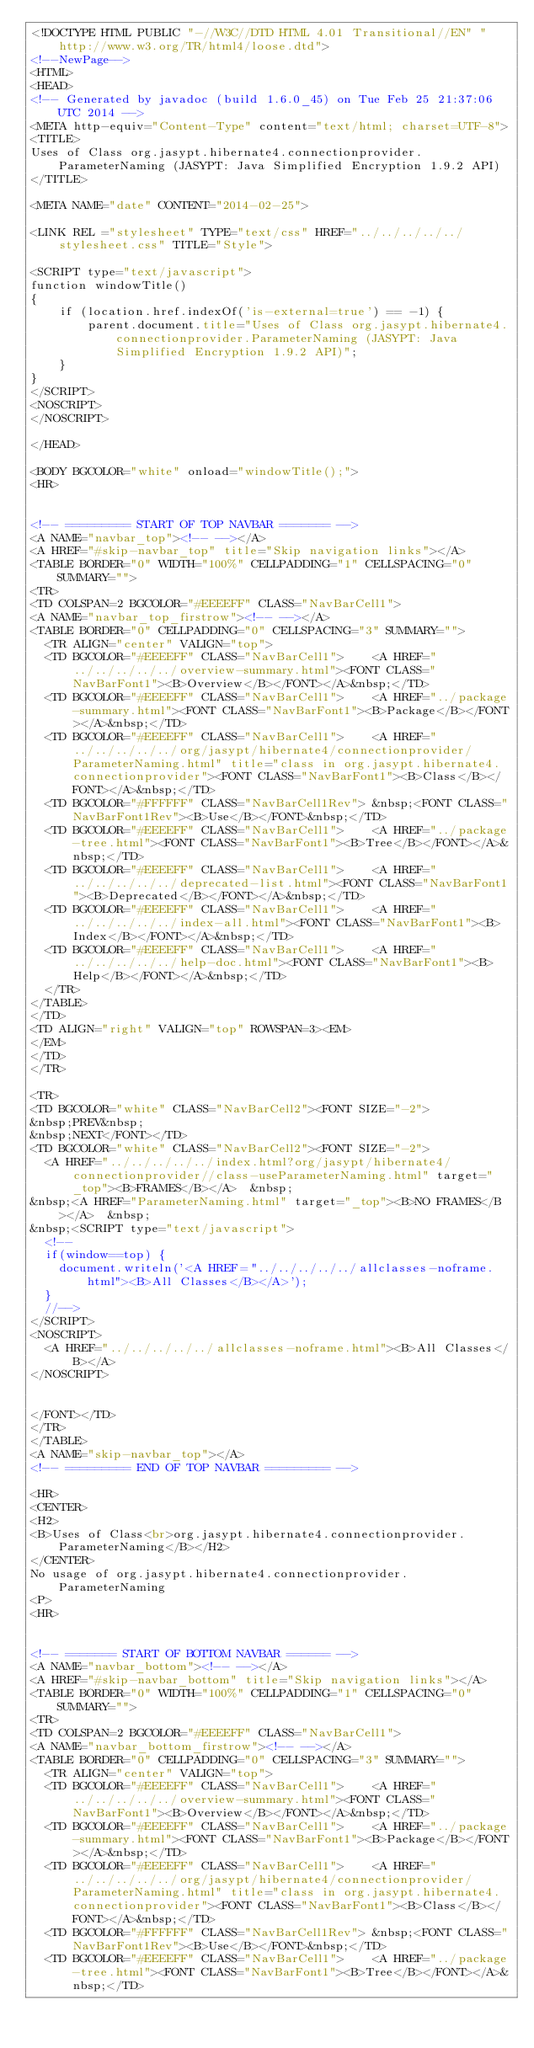Convert code to text. <code><loc_0><loc_0><loc_500><loc_500><_HTML_><!DOCTYPE HTML PUBLIC "-//W3C//DTD HTML 4.01 Transitional//EN" "http://www.w3.org/TR/html4/loose.dtd">
<!--NewPage-->
<HTML>
<HEAD>
<!-- Generated by javadoc (build 1.6.0_45) on Tue Feb 25 21:37:06 UTC 2014 -->
<META http-equiv="Content-Type" content="text/html; charset=UTF-8">
<TITLE>
Uses of Class org.jasypt.hibernate4.connectionprovider.ParameterNaming (JASYPT: Java Simplified Encryption 1.9.2 API)
</TITLE>

<META NAME="date" CONTENT="2014-02-25">

<LINK REL ="stylesheet" TYPE="text/css" HREF="../../../../../stylesheet.css" TITLE="Style">

<SCRIPT type="text/javascript">
function windowTitle()
{
    if (location.href.indexOf('is-external=true') == -1) {
        parent.document.title="Uses of Class org.jasypt.hibernate4.connectionprovider.ParameterNaming (JASYPT: Java Simplified Encryption 1.9.2 API)";
    }
}
</SCRIPT>
<NOSCRIPT>
</NOSCRIPT>

</HEAD>

<BODY BGCOLOR="white" onload="windowTitle();">
<HR>


<!-- ========= START OF TOP NAVBAR ======= -->
<A NAME="navbar_top"><!-- --></A>
<A HREF="#skip-navbar_top" title="Skip navigation links"></A>
<TABLE BORDER="0" WIDTH="100%" CELLPADDING="1" CELLSPACING="0" SUMMARY="">
<TR>
<TD COLSPAN=2 BGCOLOR="#EEEEFF" CLASS="NavBarCell1">
<A NAME="navbar_top_firstrow"><!-- --></A>
<TABLE BORDER="0" CELLPADDING="0" CELLSPACING="3" SUMMARY="">
  <TR ALIGN="center" VALIGN="top">
  <TD BGCOLOR="#EEEEFF" CLASS="NavBarCell1">    <A HREF="../../../../../overview-summary.html"><FONT CLASS="NavBarFont1"><B>Overview</B></FONT></A>&nbsp;</TD>
  <TD BGCOLOR="#EEEEFF" CLASS="NavBarCell1">    <A HREF="../package-summary.html"><FONT CLASS="NavBarFont1"><B>Package</B></FONT></A>&nbsp;</TD>
  <TD BGCOLOR="#EEEEFF" CLASS="NavBarCell1">    <A HREF="../../../../../org/jasypt/hibernate4/connectionprovider/ParameterNaming.html" title="class in org.jasypt.hibernate4.connectionprovider"><FONT CLASS="NavBarFont1"><B>Class</B></FONT></A>&nbsp;</TD>
  <TD BGCOLOR="#FFFFFF" CLASS="NavBarCell1Rev"> &nbsp;<FONT CLASS="NavBarFont1Rev"><B>Use</B></FONT>&nbsp;</TD>
  <TD BGCOLOR="#EEEEFF" CLASS="NavBarCell1">    <A HREF="../package-tree.html"><FONT CLASS="NavBarFont1"><B>Tree</B></FONT></A>&nbsp;</TD>
  <TD BGCOLOR="#EEEEFF" CLASS="NavBarCell1">    <A HREF="../../../../../deprecated-list.html"><FONT CLASS="NavBarFont1"><B>Deprecated</B></FONT></A>&nbsp;</TD>
  <TD BGCOLOR="#EEEEFF" CLASS="NavBarCell1">    <A HREF="../../../../../index-all.html"><FONT CLASS="NavBarFont1"><B>Index</B></FONT></A>&nbsp;</TD>
  <TD BGCOLOR="#EEEEFF" CLASS="NavBarCell1">    <A HREF="../../../../../help-doc.html"><FONT CLASS="NavBarFont1"><B>Help</B></FONT></A>&nbsp;</TD>
  </TR>
</TABLE>
</TD>
<TD ALIGN="right" VALIGN="top" ROWSPAN=3><EM>
</EM>
</TD>
</TR>

<TR>
<TD BGCOLOR="white" CLASS="NavBarCell2"><FONT SIZE="-2">
&nbsp;PREV&nbsp;
&nbsp;NEXT</FONT></TD>
<TD BGCOLOR="white" CLASS="NavBarCell2"><FONT SIZE="-2">
  <A HREF="../../../../../index.html?org/jasypt/hibernate4/connectionprovider//class-useParameterNaming.html" target="_top"><B>FRAMES</B></A>  &nbsp;
&nbsp;<A HREF="ParameterNaming.html" target="_top"><B>NO FRAMES</B></A>  &nbsp;
&nbsp;<SCRIPT type="text/javascript">
  <!--
  if(window==top) {
    document.writeln('<A HREF="../../../../../allclasses-noframe.html"><B>All Classes</B></A>');
  }
  //-->
</SCRIPT>
<NOSCRIPT>
  <A HREF="../../../../../allclasses-noframe.html"><B>All Classes</B></A>
</NOSCRIPT>


</FONT></TD>
</TR>
</TABLE>
<A NAME="skip-navbar_top"></A>
<!-- ========= END OF TOP NAVBAR ========= -->

<HR>
<CENTER>
<H2>
<B>Uses of Class<br>org.jasypt.hibernate4.connectionprovider.ParameterNaming</B></H2>
</CENTER>
No usage of org.jasypt.hibernate4.connectionprovider.ParameterNaming
<P>
<HR>


<!-- ======= START OF BOTTOM NAVBAR ====== -->
<A NAME="navbar_bottom"><!-- --></A>
<A HREF="#skip-navbar_bottom" title="Skip navigation links"></A>
<TABLE BORDER="0" WIDTH="100%" CELLPADDING="1" CELLSPACING="0" SUMMARY="">
<TR>
<TD COLSPAN=2 BGCOLOR="#EEEEFF" CLASS="NavBarCell1">
<A NAME="navbar_bottom_firstrow"><!-- --></A>
<TABLE BORDER="0" CELLPADDING="0" CELLSPACING="3" SUMMARY="">
  <TR ALIGN="center" VALIGN="top">
  <TD BGCOLOR="#EEEEFF" CLASS="NavBarCell1">    <A HREF="../../../../../overview-summary.html"><FONT CLASS="NavBarFont1"><B>Overview</B></FONT></A>&nbsp;</TD>
  <TD BGCOLOR="#EEEEFF" CLASS="NavBarCell1">    <A HREF="../package-summary.html"><FONT CLASS="NavBarFont1"><B>Package</B></FONT></A>&nbsp;</TD>
  <TD BGCOLOR="#EEEEFF" CLASS="NavBarCell1">    <A HREF="../../../../../org/jasypt/hibernate4/connectionprovider/ParameterNaming.html" title="class in org.jasypt.hibernate4.connectionprovider"><FONT CLASS="NavBarFont1"><B>Class</B></FONT></A>&nbsp;</TD>
  <TD BGCOLOR="#FFFFFF" CLASS="NavBarCell1Rev"> &nbsp;<FONT CLASS="NavBarFont1Rev"><B>Use</B></FONT>&nbsp;</TD>
  <TD BGCOLOR="#EEEEFF" CLASS="NavBarCell1">    <A HREF="../package-tree.html"><FONT CLASS="NavBarFont1"><B>Tree</B></FONT></A>&nbsp;</TD></code> 